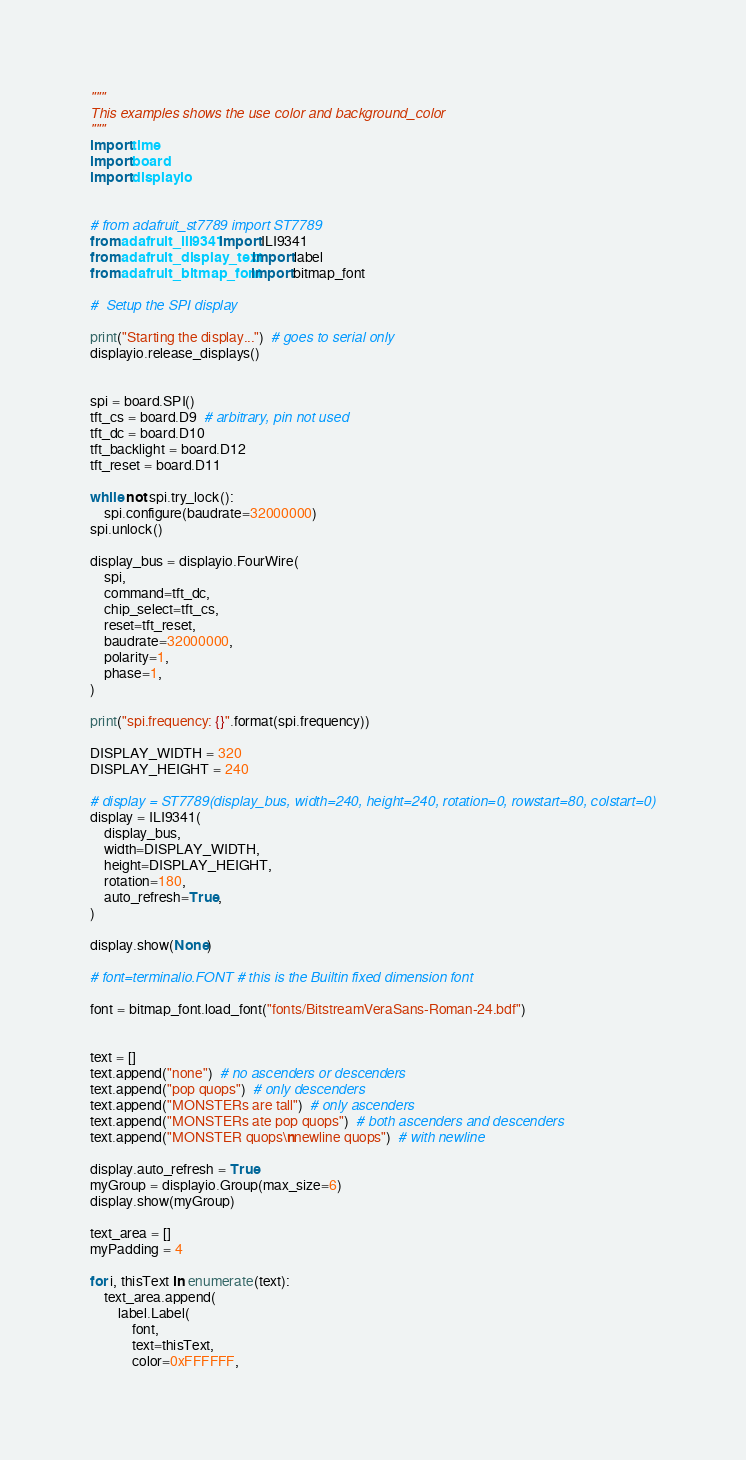<code> <loc_0><loc_0><loc_500><loc_500><_Python_>"""
This examples shows the use color and background_color
"""
import time
import board
import displayio


# from adafruit_st7789 import ST7789
from adafruit_ili9341 import ILI9341
from adafruit_display_text import label
from adafruit_bitmap_font import bitmap_font

#  Setup the SPI display

print("Starting the display...")  # goes to serial only
displayio.release_displays()


spi = board.SPI()
tft_cs = board.D9  # arbitrary, pin not used
tft_dc = board.D10
tft_backlight = board.D12
tft_reset = board.D11

while not spi.try_lock():
    spi.configure(baudrate=32000000)
spi.unlock()

display_bus = displayio.FourWire(
    spi,
    command=tft_dc,
    chip_select=tft_cs,
    reset=tft_reset,
    baudrate=32000000,
    polarity=1,
    phase=1,
)

print("spi.frequency: {}".format(spi.frequency))

DISPLAY_WIDTH = 320
DISPLAY_HEIGHT = 240

# display = ST7789(display_bus, width=240, height=240, rotation=0, rowstart=80, colstart=0)
display = ILI9341(
    display_bus,
    width=DISPLAY_WIDTH,
    height=DISPLAY_HEIGHT,
    rotation=180,
    auto_refresh=True,
)

display.show(None)

# font=terminalio.FONT # this is the Builtin fixed dimension font

font = bitmap_font.load_font("fonts/BitstreamVeraSans-Roman-24.bdf")


text = []
text.append("none")  # no ascenders or descenders
text.append("pop quops")  # only descenders
text.append("MONSTERs are tall")  # only ascenders
text.append("MONSTERs ate pop quops")  # both ascenders and descenders
text.append("MONSTER quops\nnewline quops")  # with newline

display.auto_refresh = True
myGroup = displayio.Group(max_size=6)
display.show(myGroup)

text_area = []
myPadding = 4

for i, thisText in enumerate(text):
    text_area.append(
        label.Label(
            font,
            text=thisText,
            color=0xFFFFFF,</code> 